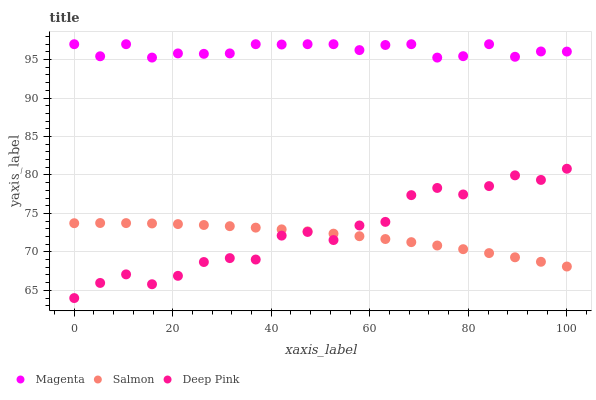Does Salmon have the minimum area under the curve?
Answer yes or no. Yes. Does Magenta have the maximum area under the curve?
Answer yes or no. Yes. Does Deep Pink have the minimum area under the curve?
Answer yes or no. No. Does Deep Pink have the maximum area under the curve?
Answer yes or no. No. Is Salmon the smoothest?
Answer yes or no. Yes. Is Deep Pink the roughest?
Answer yes or no. Yes. Is Deep Pink the smoothest?
Answer yes or no. No. Is Salmon the roughest?
Answer yes or no. No. Does Deep Pink have the lowest value?
Answer yes or no. Yes. Does Salmon have the lowest value?
Answer yes or no. No. Does Magenta have the highest value?
Answer yes or no. Yes. Does Deep Pink have the highest value?
Answer yes or no. No. Is Salmon less than Magenta?
Answer yes or no. Yes. Is Magenta greater than Deep Pink?
Answer yes or no. Yes. Does Deep Pink intersect Salmon?
Answer yes or no. Yes. Is Deep Pink less than Salmon?
Answer yes or no. No. Is Deep Pink greater than Salmon?
Answer yes or no. No. Does Salmon intersect Magenta?
Answer yes or no. No. 